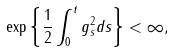Convert formula to latex. <formula><loc_0><loc_0><loc_500><loc_500>\exp \left \{ \frac { 1 } { 2 } \int _ { 0 } ^ { t } g _ { s } ^ { 2 } d s \right \} < \infty ,</formula> 